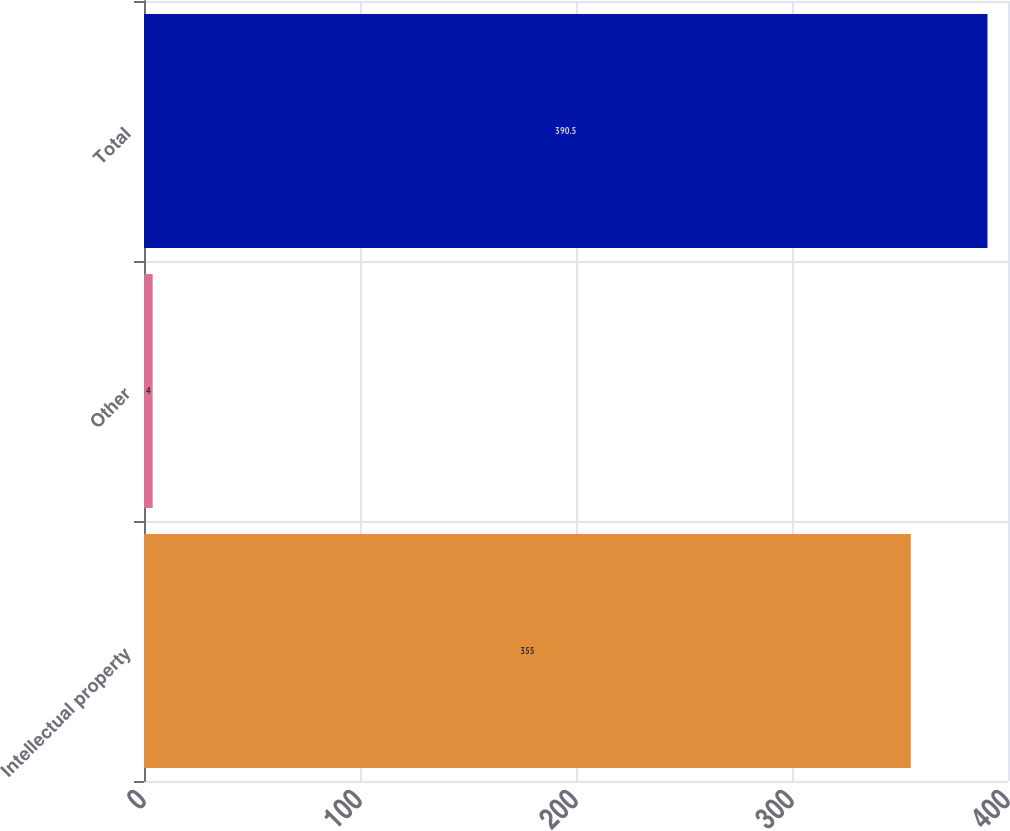Convert chart. <chart><loc_0><loc_0><loc_500><loc_500><bar_chart><fcel>Intellectual property<fcel>Other<fcel>Total<nl><fcel>355<fcel>4<fcel>390.5<nl></chart> 